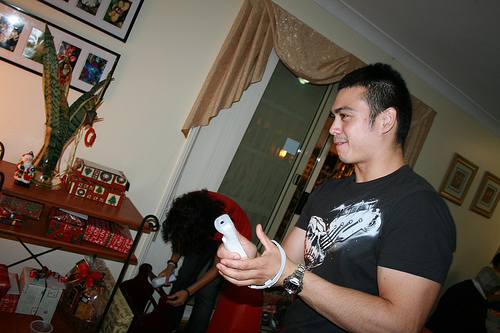<image>What time of year is it? I am unsure about the exact time of year. It might be winter or Christmas time based on the available answers. What time of year is it? I am not sure what time of year it is. It can be either winter or fall, or even during the holidays. 